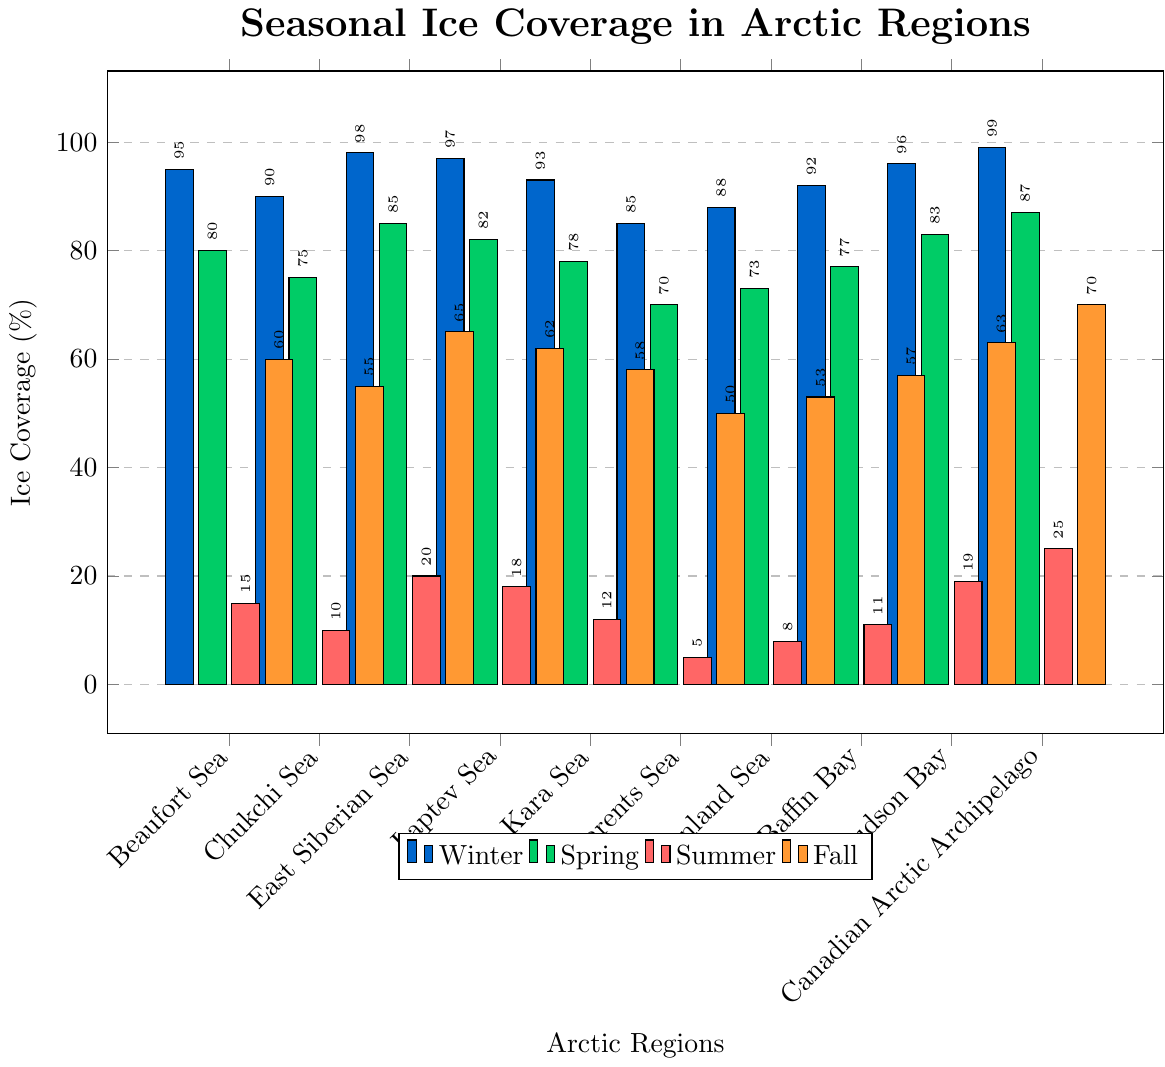What is the ice coverage in the Laptev Sea during Winter and Fall? From the figure, identify the height of the bars corresponding to Winter and Fall in the Laptev Sea region. The Winter bar for the Laptev Sea is at 97%, and the Fall bar is at 62%.
Answer: Winter: 97%, Fall: 62% Which region has the highest ice coverage in Winter? examine all the Winter bars, which are in blue, and identify the tallest one. The Canadian Arctic Archipelago has the highest Winter ice coverage at 99%.
Answer: Canadian Arctic Archipelago What is the difference in ice coverage between Spring and Summer in the Kara Sea? Locate the bars for the Kara Sea for Spring and Summer. The Spring bar is at 78%, and the Summer bar is at 12%. Subtracting these values gives the difference: 78% - 12% = 66%.
Answer: 66% Which two regions have the close ice coverage percentages during Fall? Find the regions where the Fall bars (orange) are of similar height. The Chukchi Sea and Barents Sea have Fall ice coverage of 55% and 50%, respectively, which are quite close.
Answer: Chukchi Sea and Barents Sea In which season does the Canadian Arctic Archipelago have the lowest ice coverage? Identify the shortest bar for the Canadian Arctic Archipelago out of Winter, Spring, Summer, and Fall. The Summer bar is the shortest at 25%.
Answer: Summer What is the average ice coverage in Summer across all regions? Sum up the Summer values for all regions and divide by the number of regions. The Summer values are 15, 10, 20, 18, 12, 5, 8, 11, 19, 25. Summing them gives 143. There are 10 regions, so average = 143 / 10 = 14.3%.
Answer: 14.3% Compare the ice coverage in Hudson Bay between Spring and Fall. Which season has higher ice coverage and by how much? Identify the heights of the bars in Spring and Fall for the Hudson Bay. Spring coverage is 83%, and Fall coverage is 63%. Spring coverage is higher by 83% - 63% = 20%.
Answer: Spring, 20% Which season shows the greatest variability in ice coverage across regions? Compare the range (max - min) of ice coverage values for all seasons. Winter: (99 - 85 = 14), Spring: (87 - 70 = 17), Summer: (25 - 5 = 20), Fall: (70 - 50 = 20). Summer and Fall both have the greatest variability at 20%.
Answer: Summer and Fall What is the median ice coverage value in Fall? List the Fall values and find the middle value. The Fall values are 70, 65, 63, 62, 60, 58, 57, 55, 53, 50 (sorted in descending order). The median is the middle value, so for 10 values, (58+60)/2 = 59%.
Answer: 59% How does the ice coverage in Spring compare between the East Siberian Sea and the Barents Sea? Look at the Spring bars for East Siberian Sea and Barents Sea. The East Siberian Sea has 85%, and the Barents Sea has 70%. Therefore, the East Siberian Sea has higher ice coverage by 15%.
Answer: East Siberian Sea, 15% 